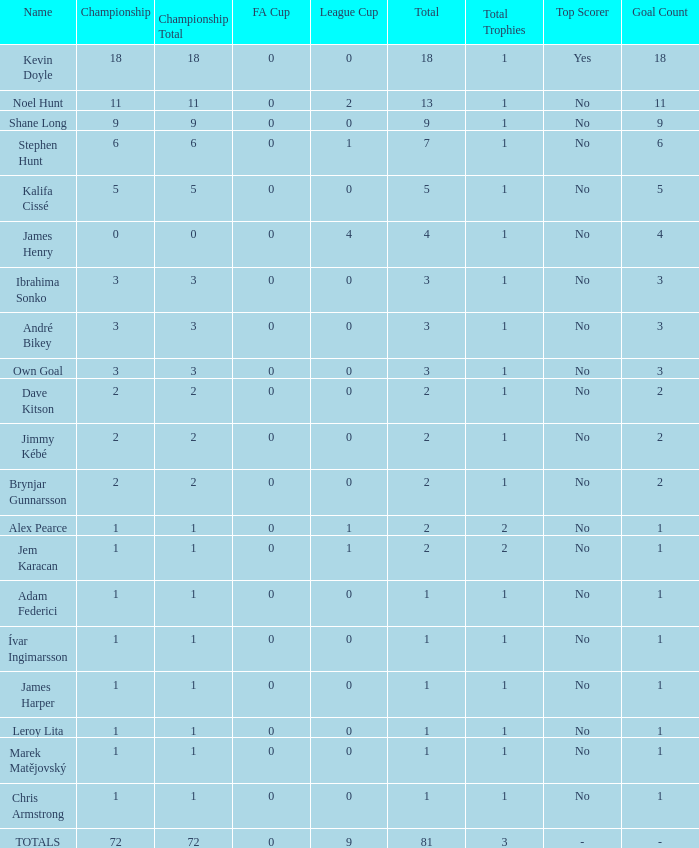What is the total championships of James Henry that has a league cup more than 1? 0.0. 